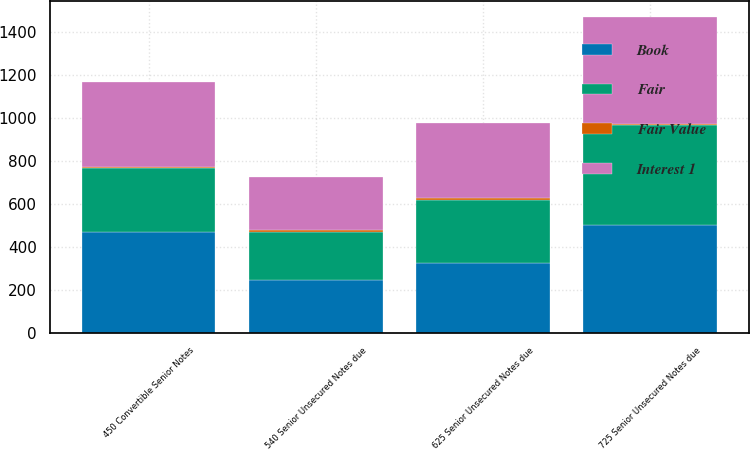Convert chart to OTSL. <chart><loc_0><loc_0><loc_500><loc_500><stacked_bar_chart><ecel><fcel>540 Senior Unsecured Notes due<fcel>725 Senior Unsecured Notes due<fcel>625 Senior Unsecured Notes due<fcel>450 Convertible Senior Notes<nl><fcel>Fair Value<fcel>5.43<fcel>7.25<fcel>6.29<fcel>4.5<nl><fcel>Interest 1<fcel>249.8<fcel>499.3<fcel>350.2<fcel>400<nl><fcel>Book<fcel>245<fcel>500<fcel>322<fcel>467.2<nl><fcel>Fair<fcel>225<fcel>465<fcel>297.5<fcel>297.5<nl></chart> 